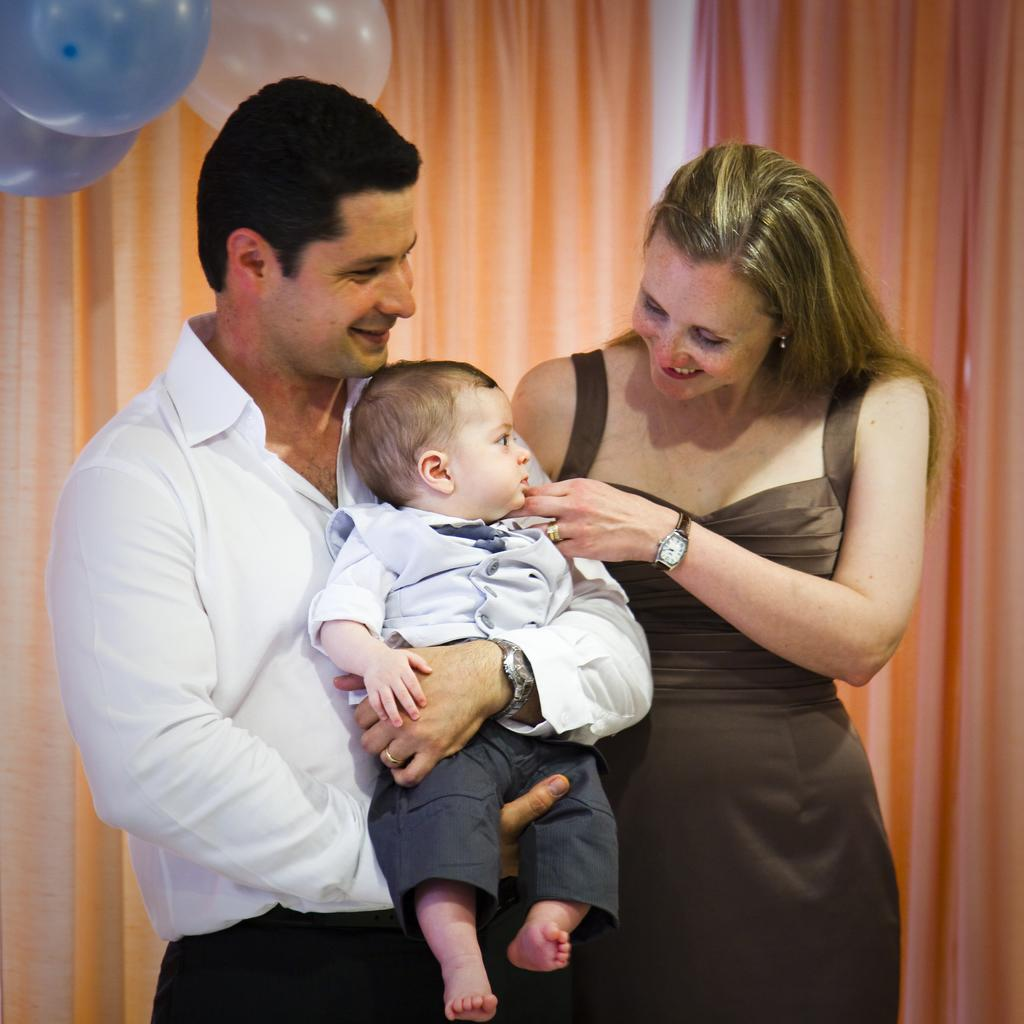What is the man in the image doing with the kid? The man is holding a kid in the image. Can you describe the woman in the image? There is a lady in the image. What can be seen in the background of the image? There are balloons and a curtain in the background of the image. What is the man's reaction to the van in the image? There is no van present in the image, so it is not possible to determine the man's reaction to it. 